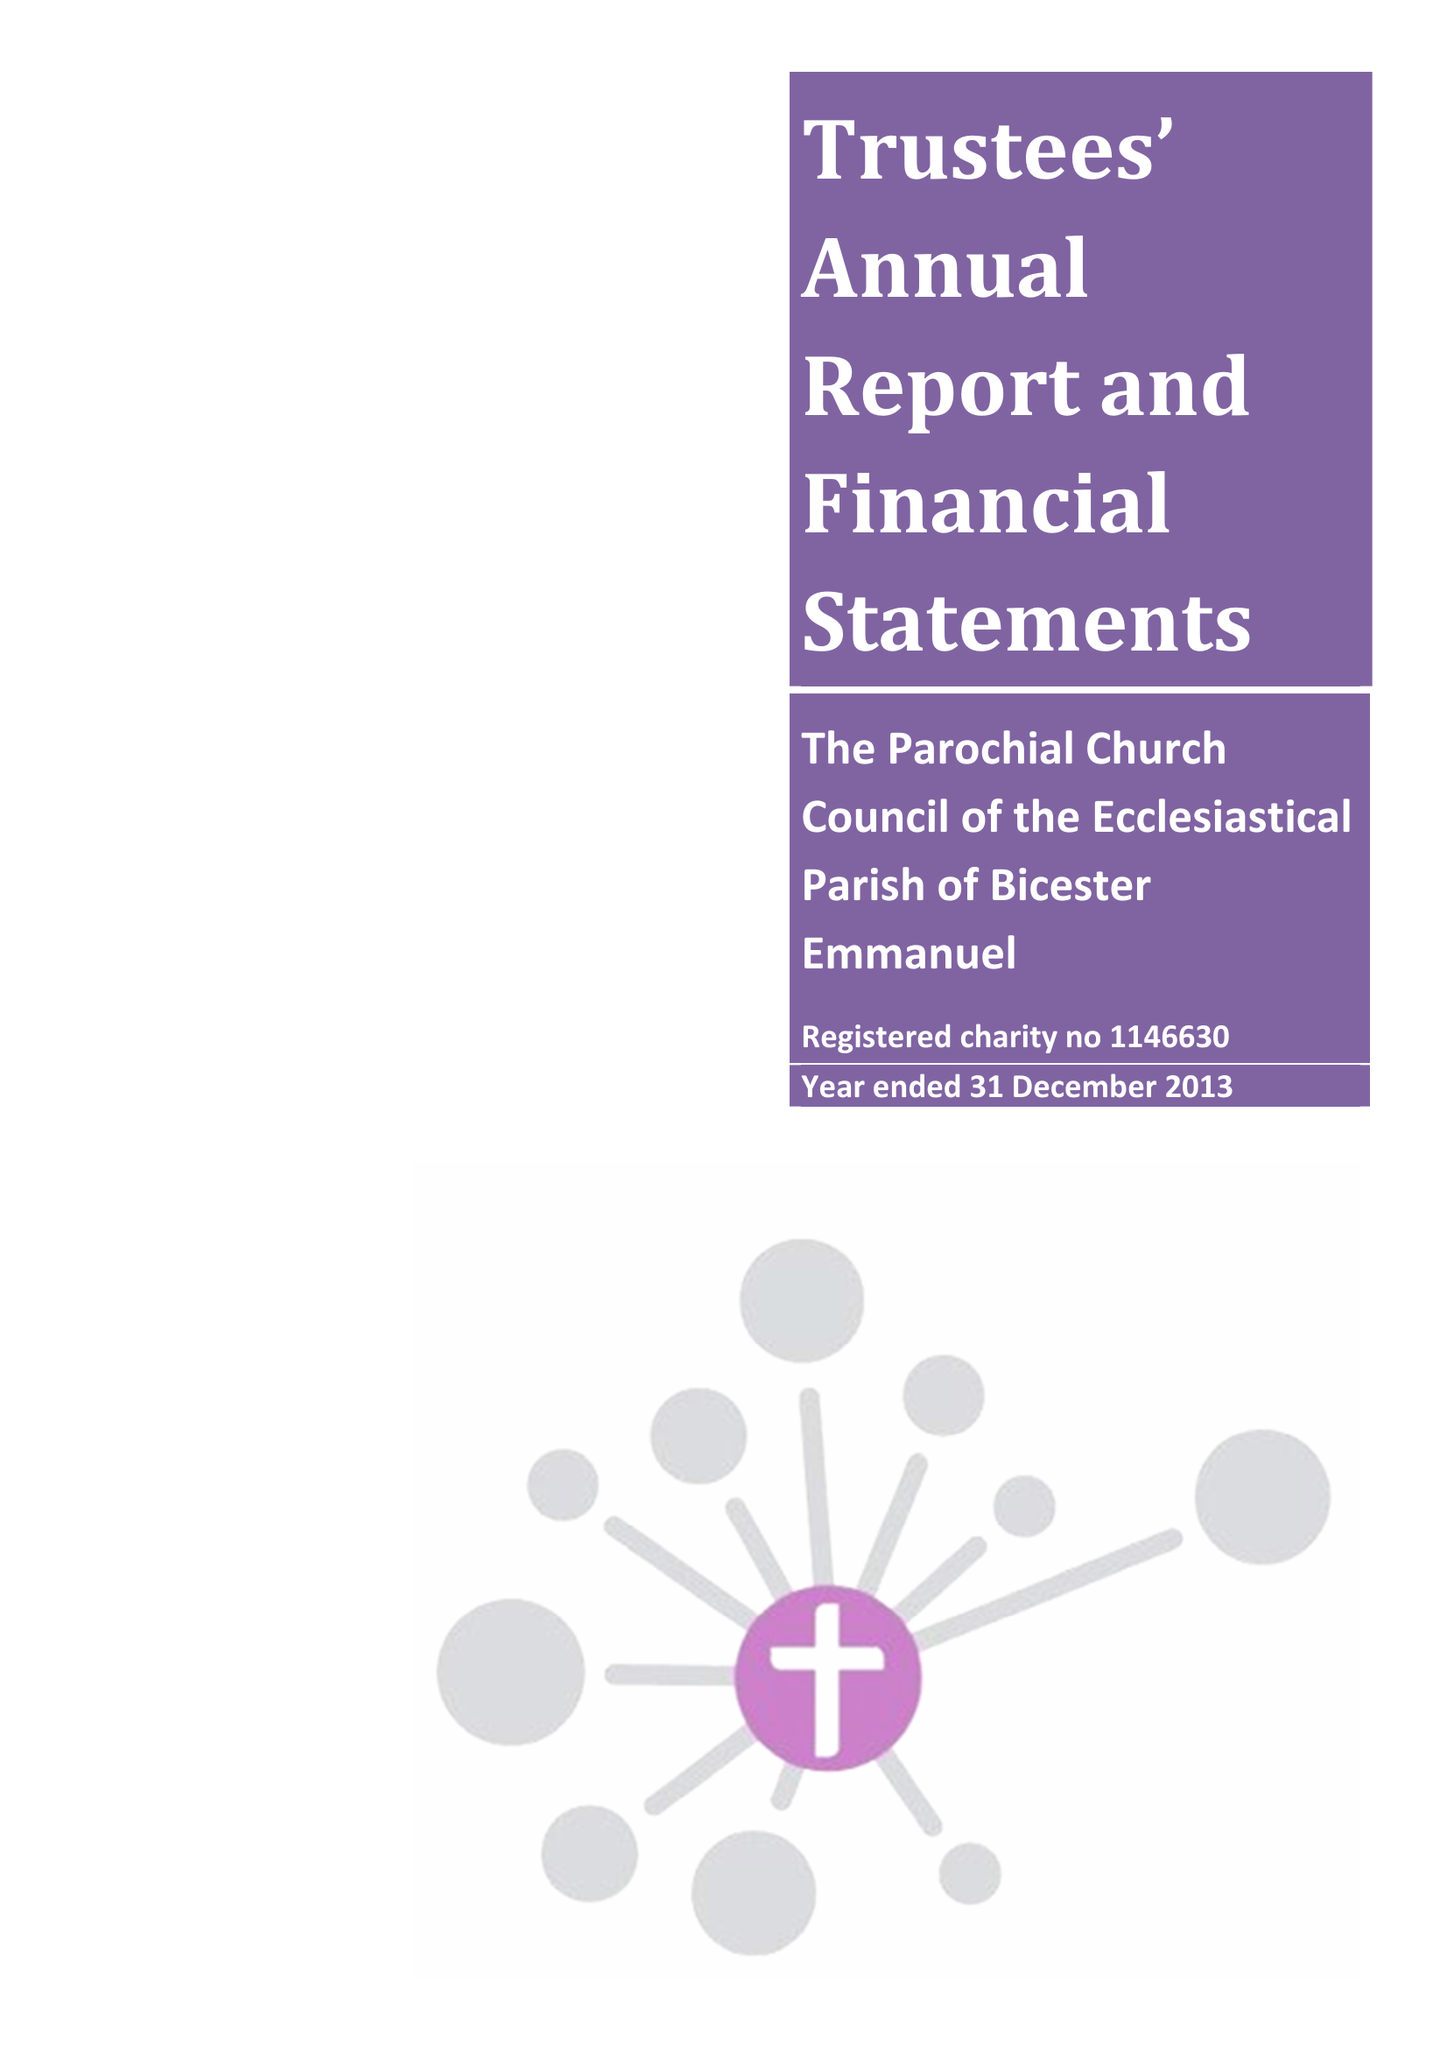What is the value for the charity_name?
Answer the question using a single word or phrase. The Parochial Church Council Of The Ecclesiastical Parish Of Bicester Emmanuel 